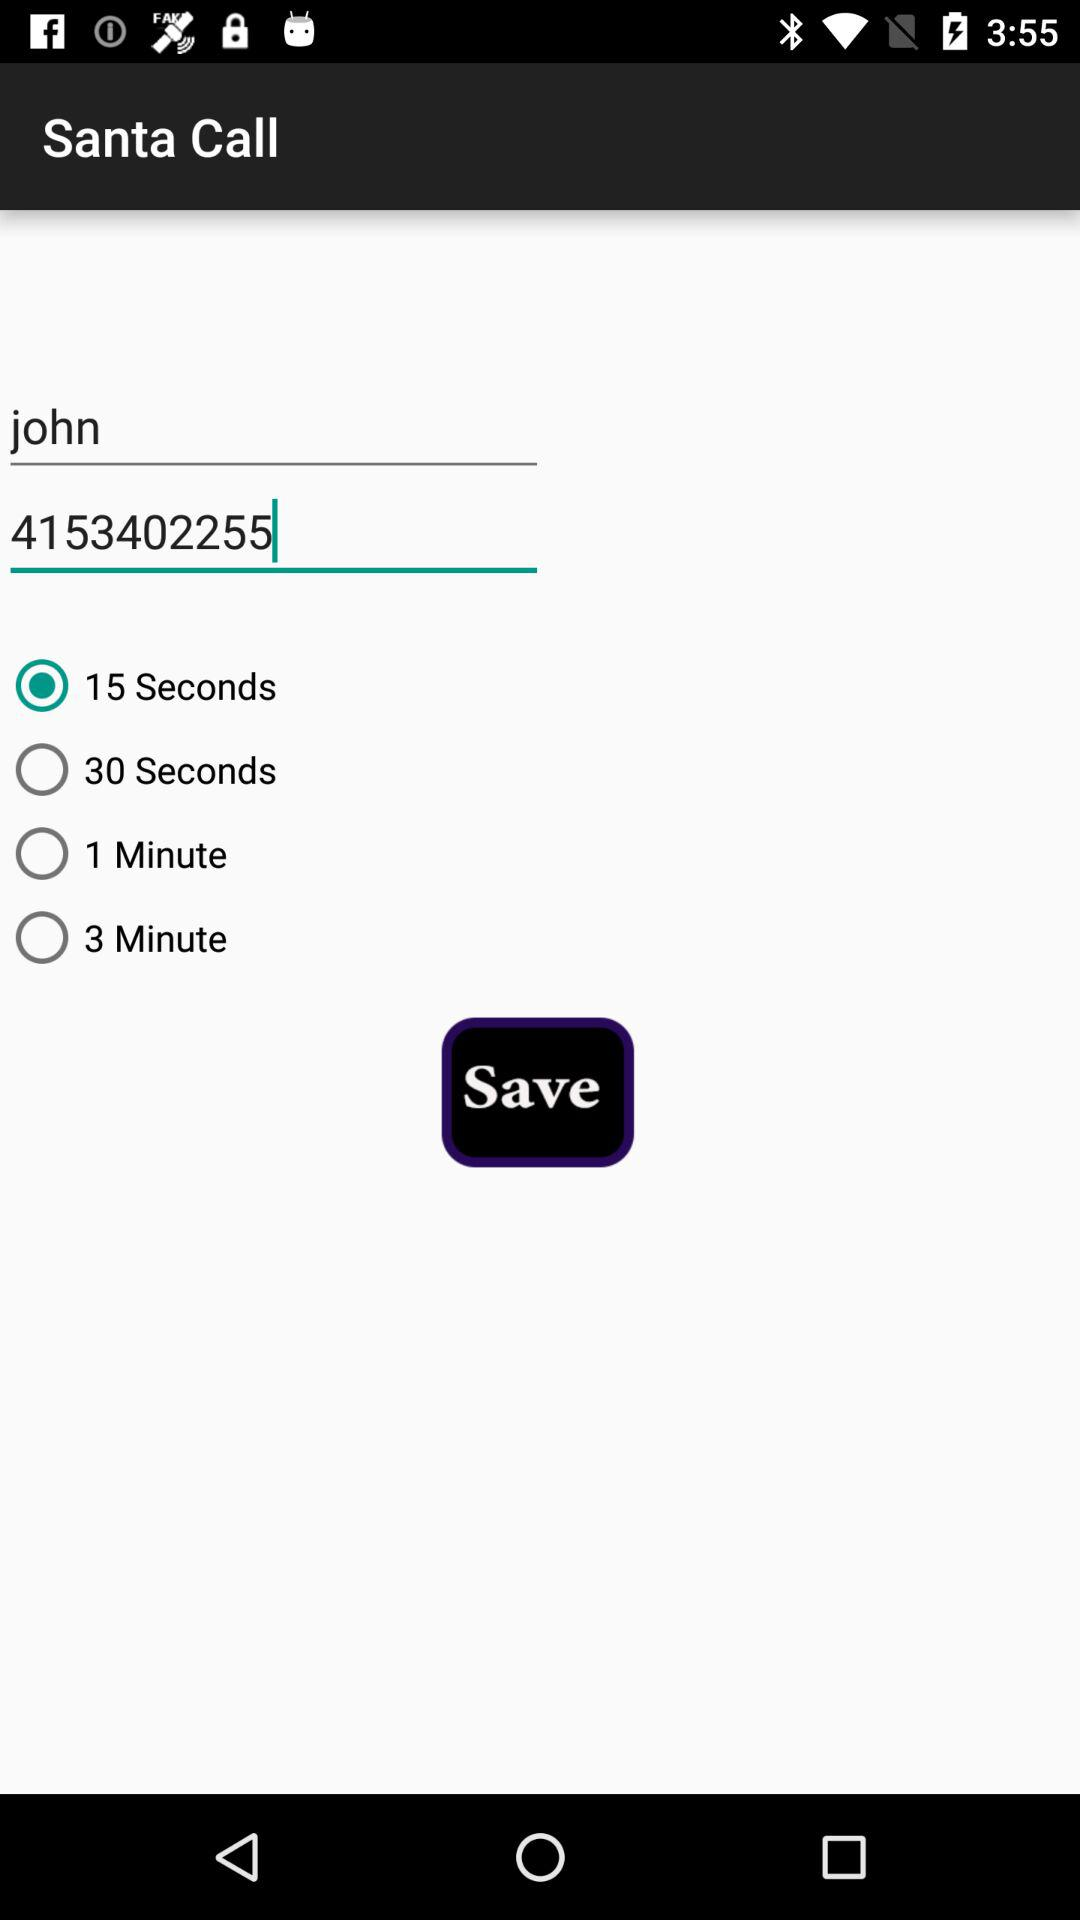What is the user name? The user name is John. 